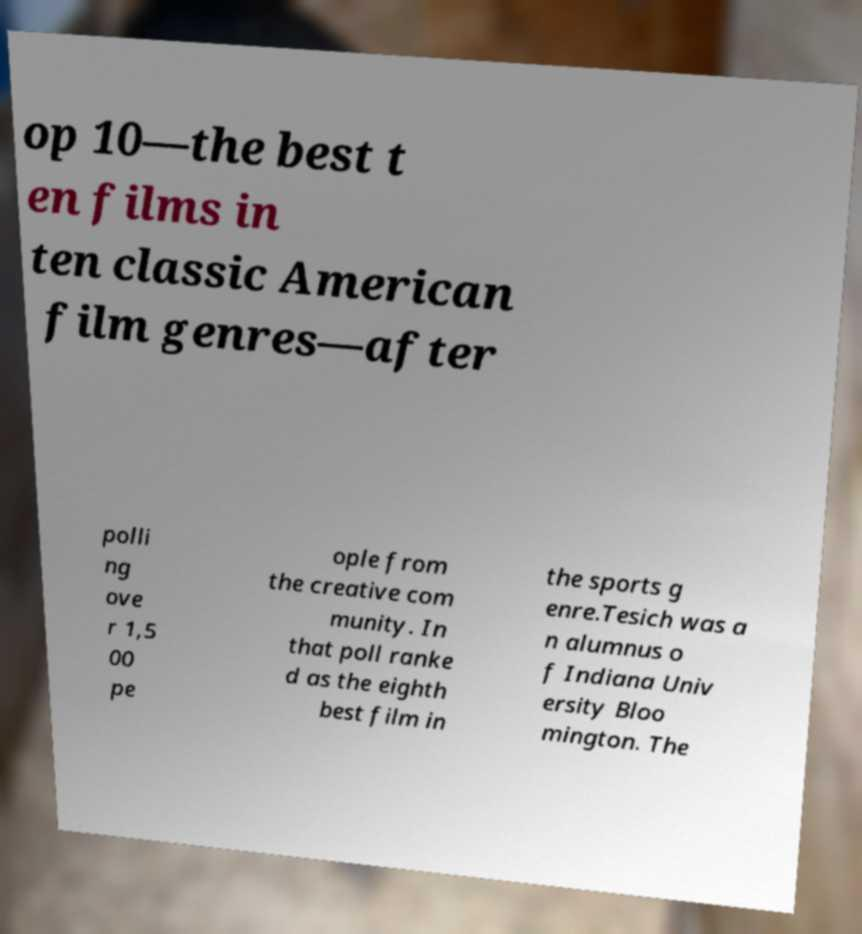Could you assist in decoding the text presented in this image and type it out clearly? op 10—the best t en films in ten classic American film genres—after polli ng ove r 1,5 00 pe ople from the creative com munity. In that poll ranke d as the eighth best film in the sports g enre.Tesich was a n alumnus o f Indiana Univ ersity Bloo mington. The 